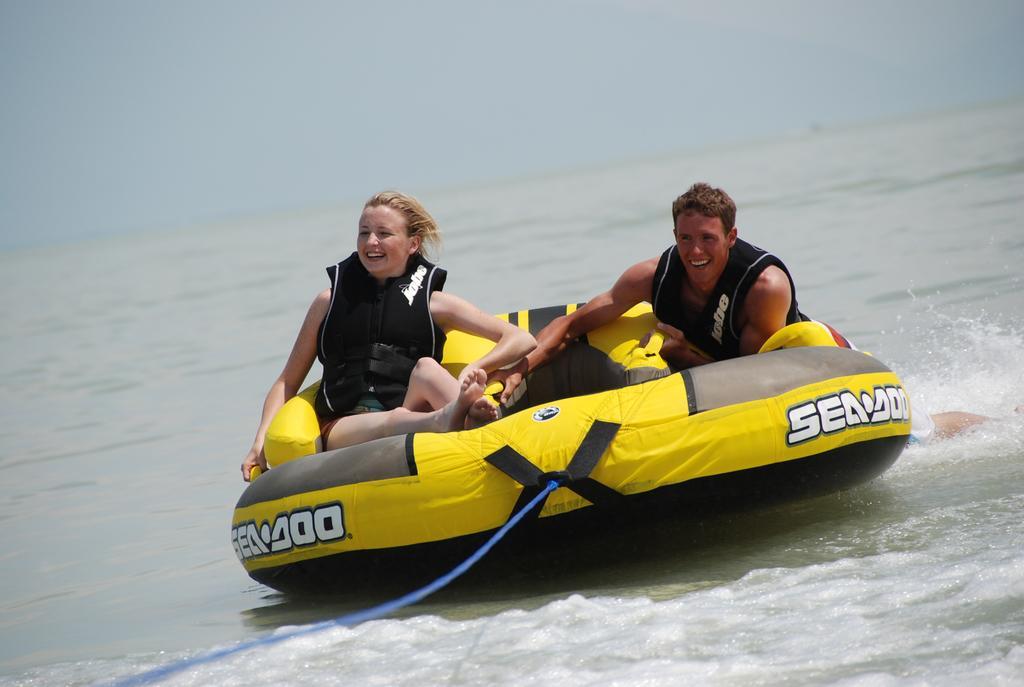In one or two sentences, can you explain what this image depicts? In this image, in the middle, we can see two people man and woman are sitting on the boat. In the middle of the image, we can see a wire which is in blue color and the wire is attached to a boat. In the background, we can see water in an ocean. At the top, we can see a sky. 